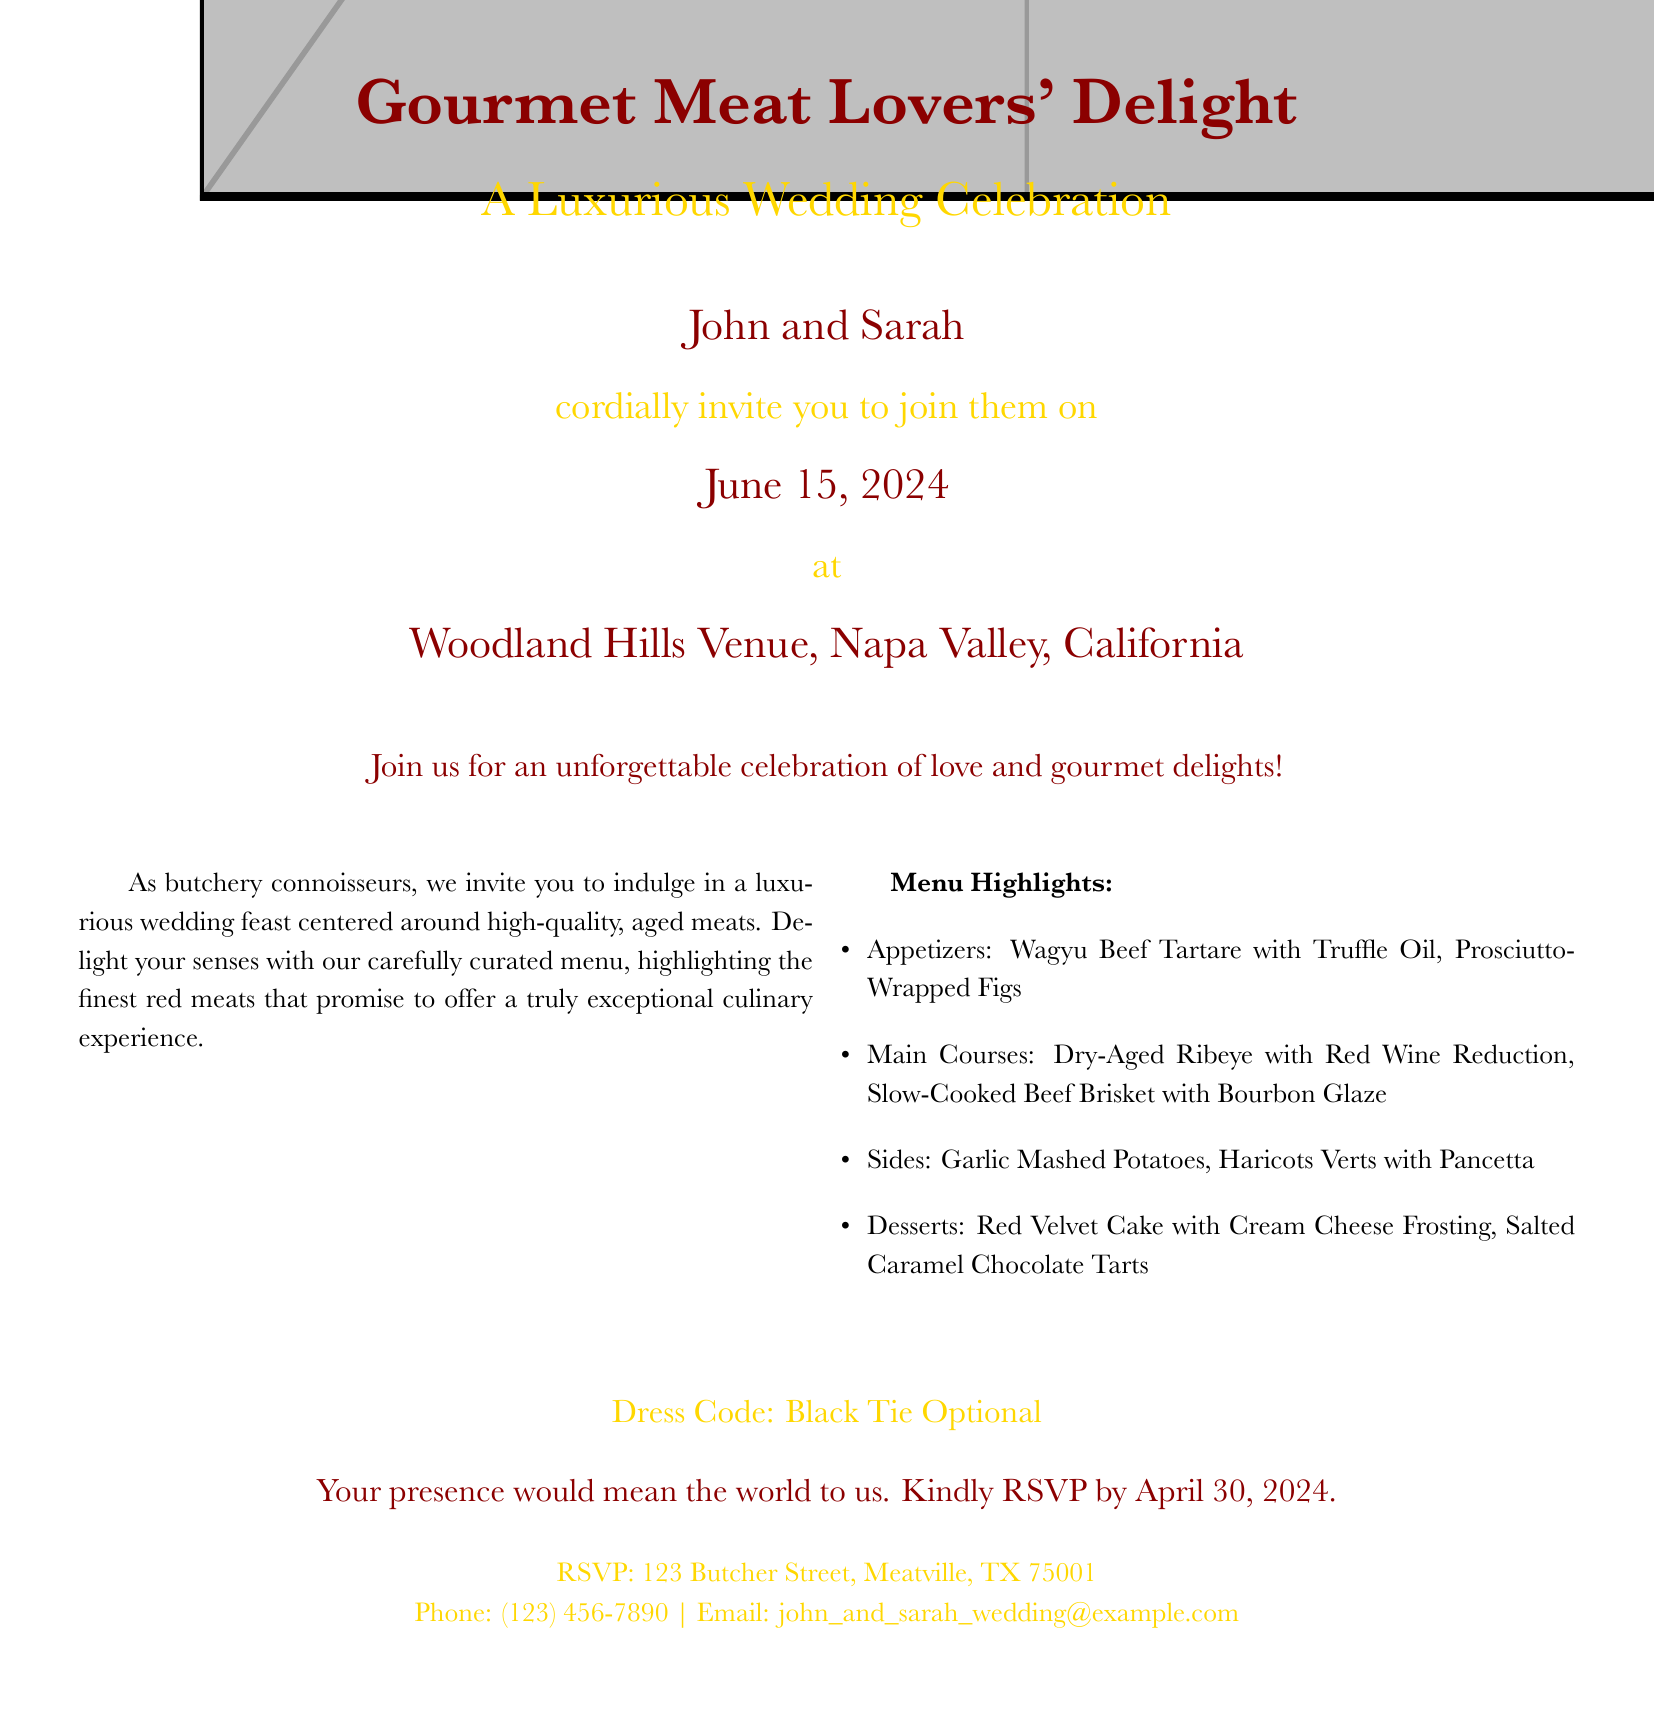What is the name of the couple getting married? The document mentions the couple's names at the beginning.
Answer: John and Sarah What is the date of the wedding? The wedding date is specified in the invitation.
Answer: June 15, 2024 Where is the wedding venue located? The venue is mentioned in the details of the invitation.
Answer: Woodland Hills Venue, Napa Valley, California What is the dress code for the wedding? The document states the dress code towards the end.
Answer: Black Tie Optional What type of cuisine is featured at the wedding? The invitation highlights the focus of the wedding cuisine.
Answer: Gourmet red meat dishes What is one of the appetizers listed on the menu? The menu section includes specific items served at the wedding.
Answer: Wagyu Beef Tartare with Truffle Oil When is the RSVP deadline? The RSVP deadline is provided in the invitation.
Answer: April 30, 2024 What is the address for RSVPs? The RSVP address is mentioned in the invitation.
Answer: 123 Butcher Street, Meatville, TX 75001 What is one of the desserts featured in the wedding menu? The document lists dessert options in the menu.
Answer: Red Velvet Cake with Cream Cheese Frosting 